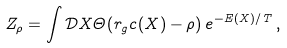Convert formula to latex. <formula><loc_0><loc_0><loc_500><loc_500>Z _ { \rho } = \int \mathcal { D } X \Theta ( r _ { g } c ( X ) - \rho ) \, e ^ { - E ( X ) / { T } } \, ,</formula> 